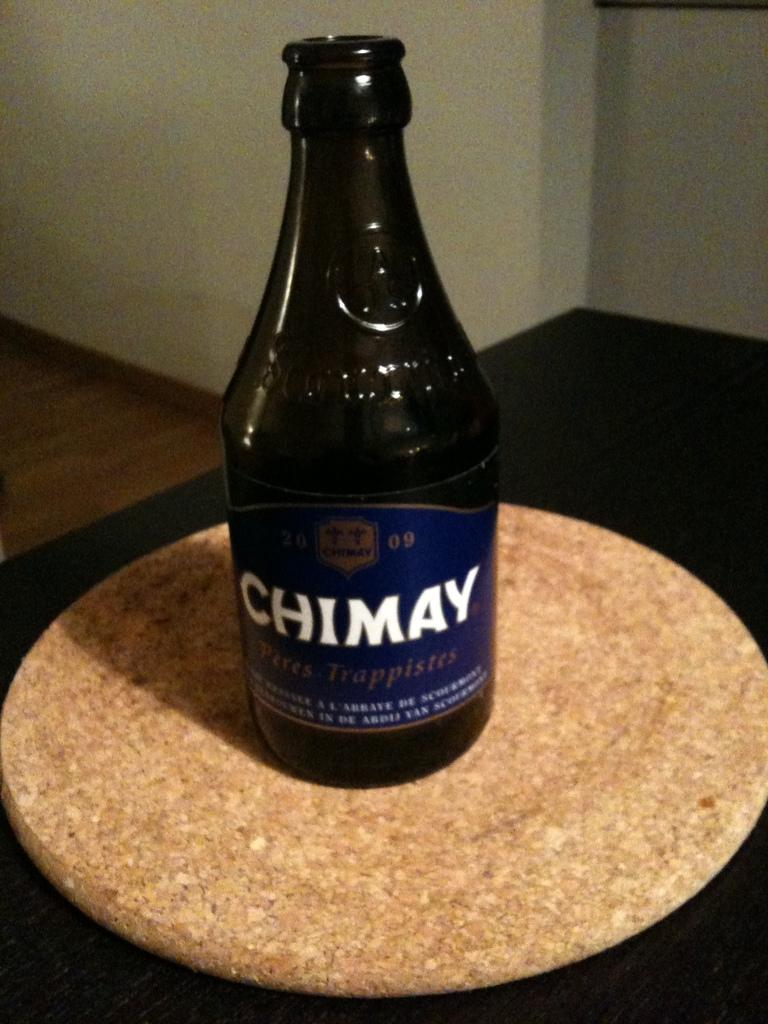<image>
Write a terse but informative summary of the picture. A bottle with a blue label of Chimay on top of round disk displayed on a table. 